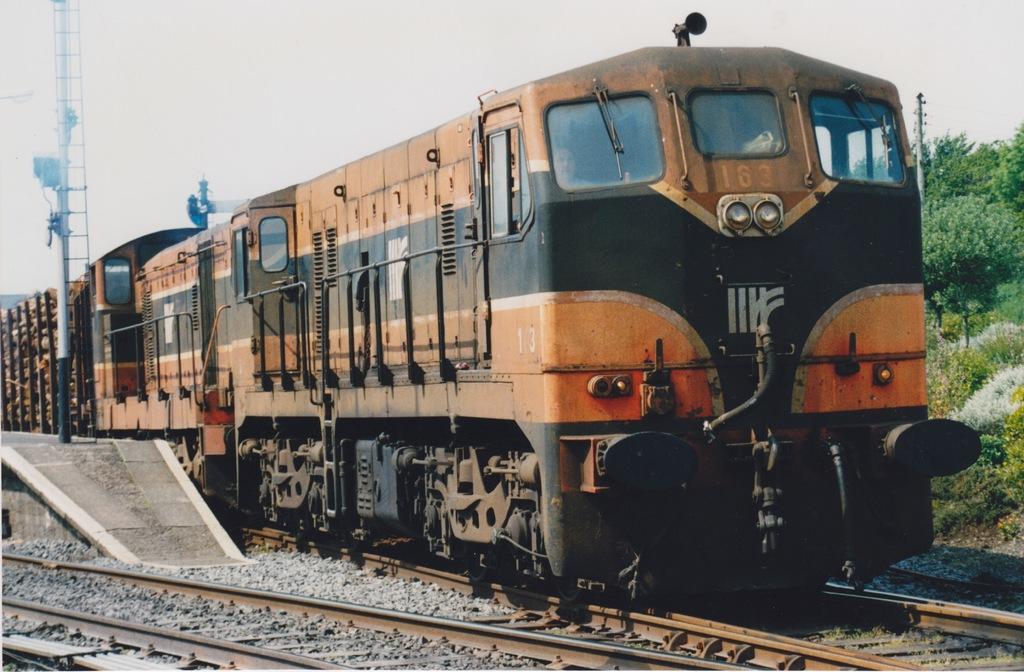Describe this image in one or two sentences. In this picture we can see two railway tracks at the bottom, on the right side we can see trees and plants, there is a train traveling on the track, on the left side there is a pole, we can see the sky at the top of the picture, there are some stones at the bottom. 